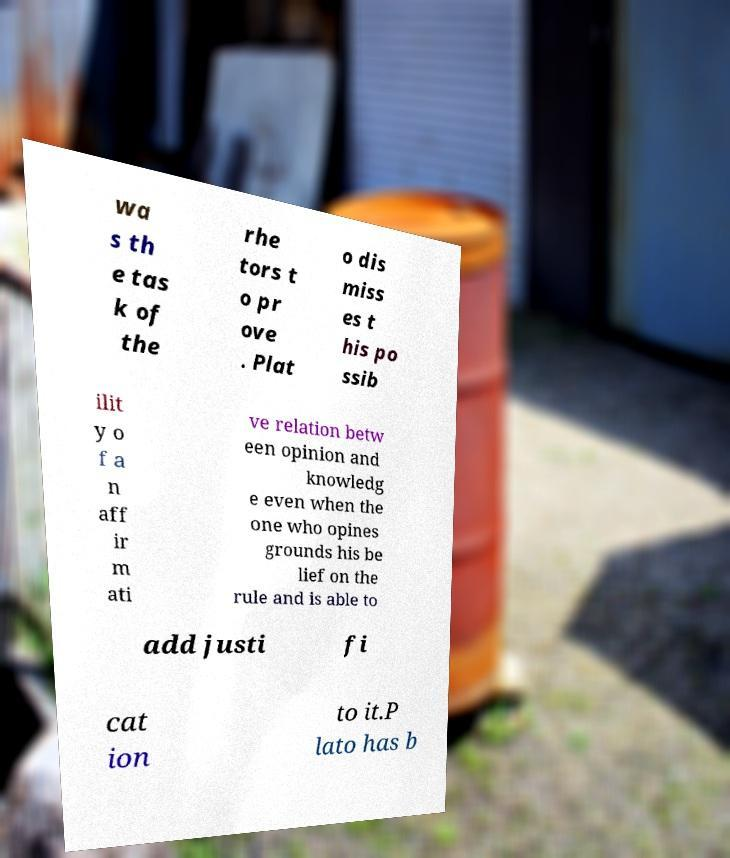Could you assist in decoding the text presented in this image and type it out clearly? wa s th e tas k of the rhe tors t o pr ove . Plat o dis miss es t his po ssib ilit y o f a n aff ir m ati ve relation betw een opinion and knowledg e even when the one who opines grounds his be lief on the rule and is able to add justi fi cat ion to it.P lato has b 